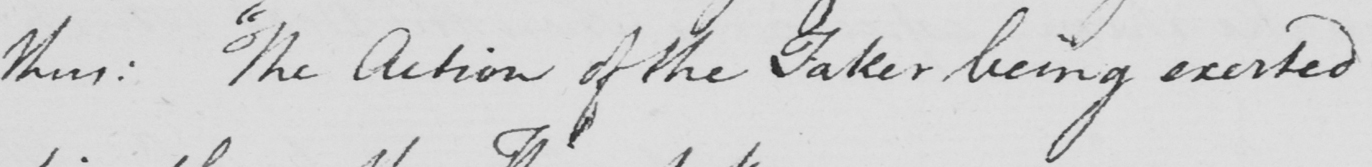Can you read and transcribe this handwriting? thus :   " The Action of the Taker being exerted 